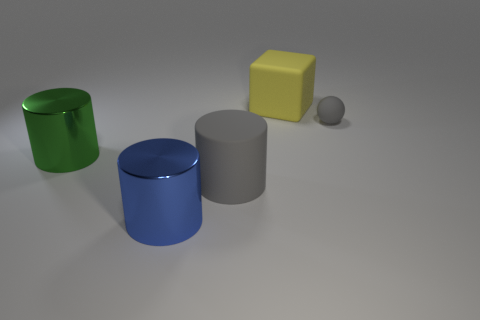If these objects were containers, which one would hold the most volume? Assuming the objects are hollow containers with open tops, the large green cylinder would hold the most volume due to its height and diameter. Volume is calculated as the area of the base multiplied by the height, and the green cylinder's dimensions suggest it would have the largest capacity among the depicted objects. 